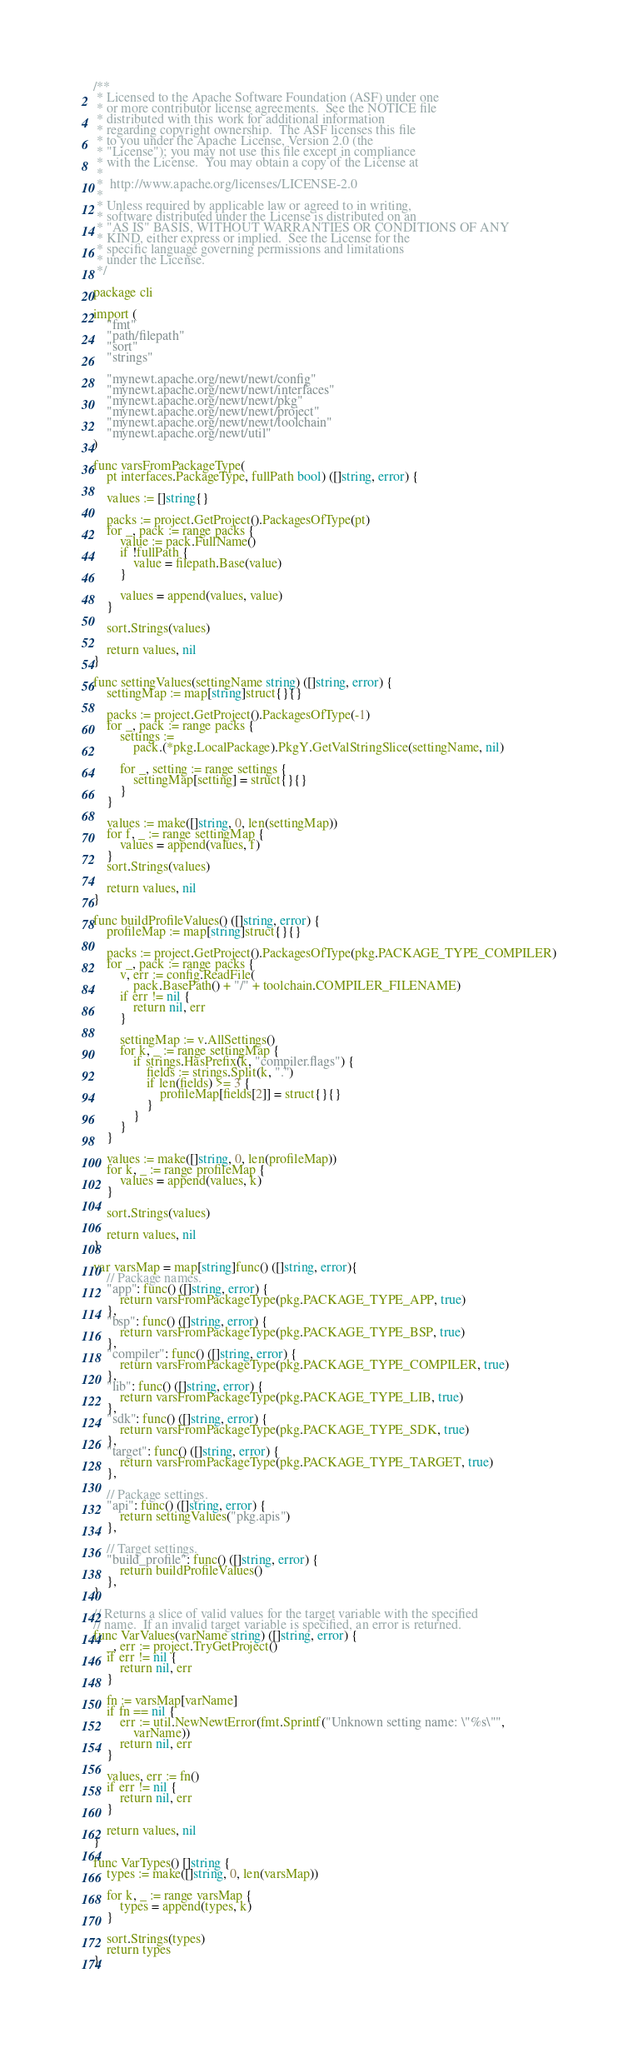Convert code to text. <code><loc_0><loc_0><loc_500><loc_500><_Go_>/**
 * Licensed to the Apache Software Foundation (ASF) under one
 * or more contributor license agreements.  See the NOTICE file
 * distributed with this work for additional information
 * regarding copyright ownership.  The ASF licenses this file
 * to you under the Apache License, Version 2.0 (the
 * "License"); you may not use this file except in compliance
 * with the License.  You may obtain a copy of the License at
 *
 *  http://www.apache.org/licenses/LICENSE-2.0
 *
 * Unless required by applicable law or agreed to in writing,
 * software distributed under the License is distributed on an
 * "AS IS" BASIS, WITHOUT WARRANTIES OR CONDITIONS OF ANY
 * KIND, either express or implied.  See the License for the
 * specific language governing permissions and limitations
 * under the License.
 */

package cli

import (
	"fmt"
	"path/filepath"
	"sort"
	"strings"

	"mynewt.apache.org/newt/newt/config"
	"mynewt.apache.org/newt/newt/interfaces"
	"mynewt.apache.org/newt/newt/pkg"
	"mynewt.apache.org/newt/newt/project"
	"mynewt.apache.org/newt/newt/toolchain"
	"mynewt.apache.org/newt/util"
)

func varsFromPackageType(
	pt interfaces.PackageType, fullPath bool) ([]string, error) {

	values := []string{}

	packs := project.GetProject().PackagesOfType(pt)
	for _, pack := range packs {
		value := pack.FullName()
		if !fullPath {
			value = filepath.Base(value)
		}

		values = append(values, value)
	}

	sort.Strings(values)

	return values, nil
}

func settingValues(settingName string) ([]string, error) {
	settingMap := map[string]struct{}{}

	packs := project.GetProject().PackagesOfType(-1)
	for _, pack := range packs {
		settings :=
			pack.(*pkg.LocalPackage).PkgY.GetValStringSlice(settingName, nil)

		for _, setting := range settings {
			settingMap[setting] = struct{}{}
		}
	}

	values := make([]string, 0, len(settingMap))
	for f, _ := range settingMap {
		values = append(values, f)
	}
	sort.Strings(values)

	return values, nil
}

func buildProfileValues() ([]string, error) {
	profileMap := map[string]struct{}{}

	packs := project.GetProject().PackagesOfType(pkg.PACKAGE_TYPE_COMPILER)
	for _, pack := range packs {
		v, err := config.ReadFile(
			pack.BasePath() + "/" + toolchain.COMPILER_FILENAME)
		if err != nil {
			return nil, err
		}

		settingMap := v.AllSettings()
		for k, _ := range settingMap {
			if strings.HasPrefix(k, "compiler.flags") {
				fields := strings.Split(k, ".")
				if len(fields) >= 3 {
					profileMap[fields[2]] = struct{}{}
				}
			}
		}
	}

	values := make([]string, 0, len(profileMap))
	for k, _ := range profileMap {
		values = append(values, k)
	}

	sort.Strings(values)

	return values, nil
}

var varsMap = map[string]func() ([]string, error){
	// Package names.
	"app": func() ([]string, error) {
		return varsFromPackageType(pkg.PACKAGE_TYPE_APP, true)
	},
	"bsp": func() ([]string, error) {
		return varsFromPackageType(pkg.PACKAGE_TYPE_BSP, true)
	},
	"compiler": func() ([]string, error) {
		return varsFromPackageType(pkg.PACKAGE_TYPE_COMPILER, true)
	},
	"lib": func() ([]string, error) {
		return varsFromPackageType(pkg.PACKAGE_TYPE_LIB, true)
	},
	"sdk": func() ([]string, error) {
		return varsFromPackageType(pkg.PACKAGE_TYPE_SDK, true)
	},
	"target": func() ([]string, error) {
		return varsFromPackageType(pkg.PACKAGE_TYPE_TARGET, true)
	},

	// Package settings.
	"api": func() ([]string, error) {
		return settingValues("pkg.apis")
	},

	// Target settings.
	"build_profile": func() ([]string, error) {
		return buildProfileValues()
	},
}

// Returns a slice of valid values for the target variable with the specified
// name.  If an invalid target variable is specified, an error is returned.
func VarValues(varName string) ([]string, error) {
	_, err := project.TryGetProject()
	if err != nil {
		return nil, err
	}

	fn := varsMap[varName]
	if fn == nil {
		err := util.NewNewtError(fmt.Sprintf("Unknown setting name: \"%s\"",
			varName))
		return nil, err
	}

	values, err := fn()
	if err != nil {
		return nil, err
	}

	return values, nil
}

func VarTypes() []string {
	types := make([]string, 0, len(varsMap))

	for k, _ := range varsMap {
		types = append(types, k)
	}

	sort.Strings(types)
	return types
}
</code> 